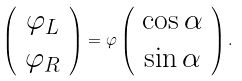Convert formula to latex. <formula><loc_0><loc_0><loc_500><loc_500>\left ( \begin{array} { c } \varphi _ { L } \\ \varphi _ { R } \end{array} \right ) = \varphi \left ( \begin{array} { c } \cos \alpha \\ \sin \alpha \end{array} \right ) .</formula> 